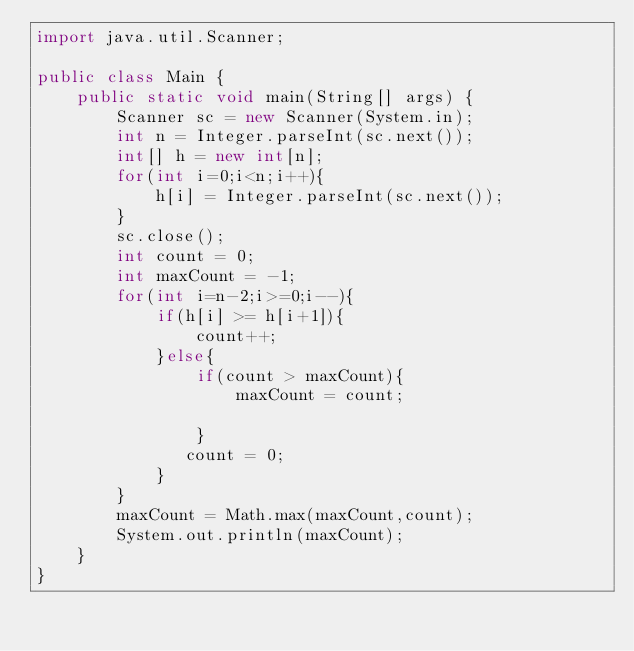<code> <loc_0><loc_0><loc_500><loc_500><_Java_>import java.util.Scanner;

public class Main {
    public static void main(String[] args) {
        Scanner sc = new Scanner(System.in);
        int n = Integer.parseInt(sc.next());
        int[] h = new int[n];
        for(int i=0;i<n;i++){
            h[i] = Integer.parseInt(sc.next());
        }
        sc.close();
        int count = 0;
        int maxCount = -1;
        for(int i=n-2;i>=0;i--){
            if(h[i] >= h[i+1]){
                count++;
            }else{
                if(count > maxCount){
                    maxCount = count;
                   
                }
               count = 0;
            }
        }
        maxCount = Math.max(maxCount,count);
        System.out.println(maxCount);
    }
}
</code> 